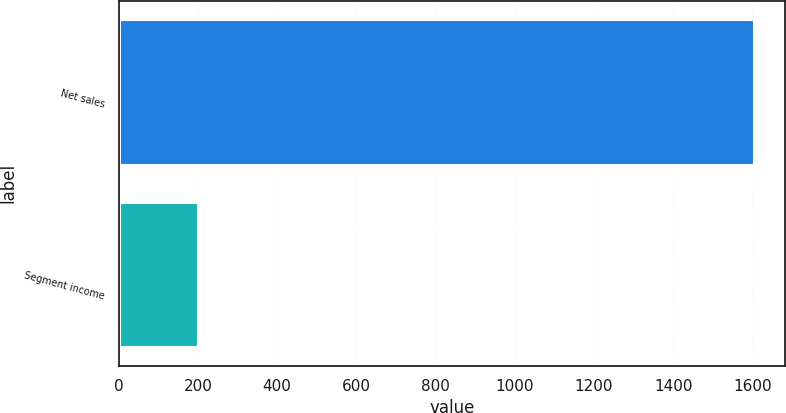<chart> <loc_0><loc_0><loc_500><loc_500><bar_chart><fcel>Net sales<fcel>Segment income<nl><fcel>1603.1<fcel>199.5<nl></chart> 